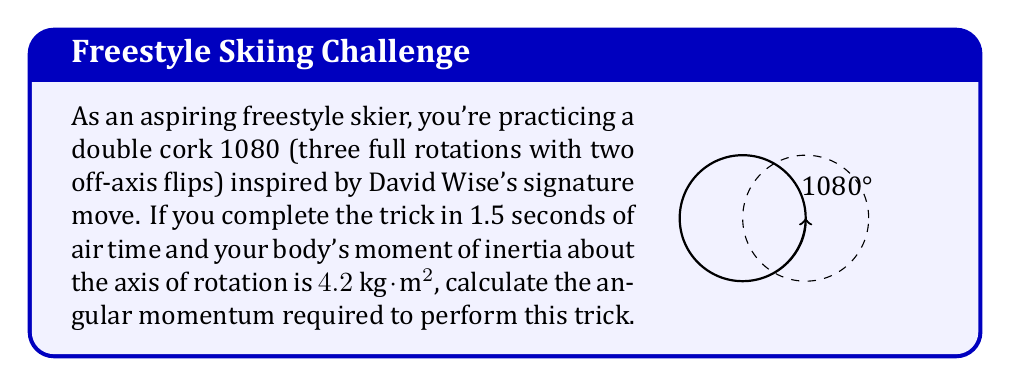Help me with this question. Let's approach this step-by-step:

1) First, we need to calculate the angular velocity ($\omega$) of the rotation:
   - One full rotation is $2\pi$ radians
   - The skier completes 3 full rotations
   - Total angular displacement: $\theta = 3 \times 2\pi = 6\pi$ radians
   - Time taken: $t = 1.5$ seconds
   - Angular velocity: $\omega = \frac{\theta}{t} = \frac{6\pi}{1.5} = 4\pi \text{ rad/s}$

2) Now, we can use the formula for angular momentum:
   $L = I\omega$
   Where:
   $L$ = angular momentum
   $I$ = moment of inertia
   $\omega$ = angular velocity

3) We have:
   $I = 4.2 \text{ kg}\cdot\text{m}^2$
   $\omega = 4\pi \text{ rad/s}$

4) Substituting these values:
   $L = 4.2 \times 4\pi = 16.8\pi \text{ kg}\cdot\text{m}^2/\text{s}$

Therefore, the angular momentum required is $16.8\pi \text{ kg}\cdot\text{m}^2/\text{s}$.
Answer: $16.8\pi \text{ kg}\cdot\text{m}^2/\text{s}$ 